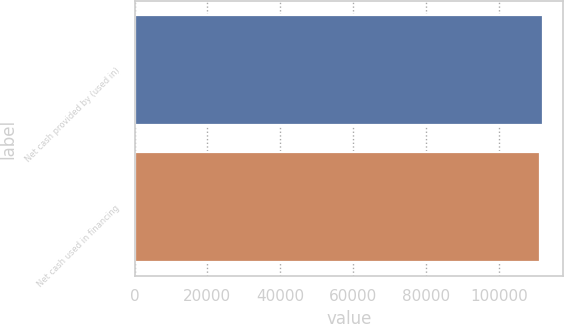Convert chart to OTSL. <chart><loc_0><loc_0><loc_500><loc_500><bar_chart><fcel>Net cash provided by (used in)<fcel>Net cash used in financing<nl><fcel>112027<fcel>111380<nl></chart> 